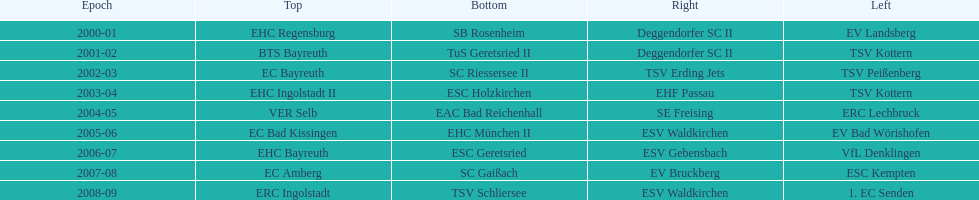In the 2006-07 season, after esc geretsried played, who came out victorious in the south? SC Gaißach. 